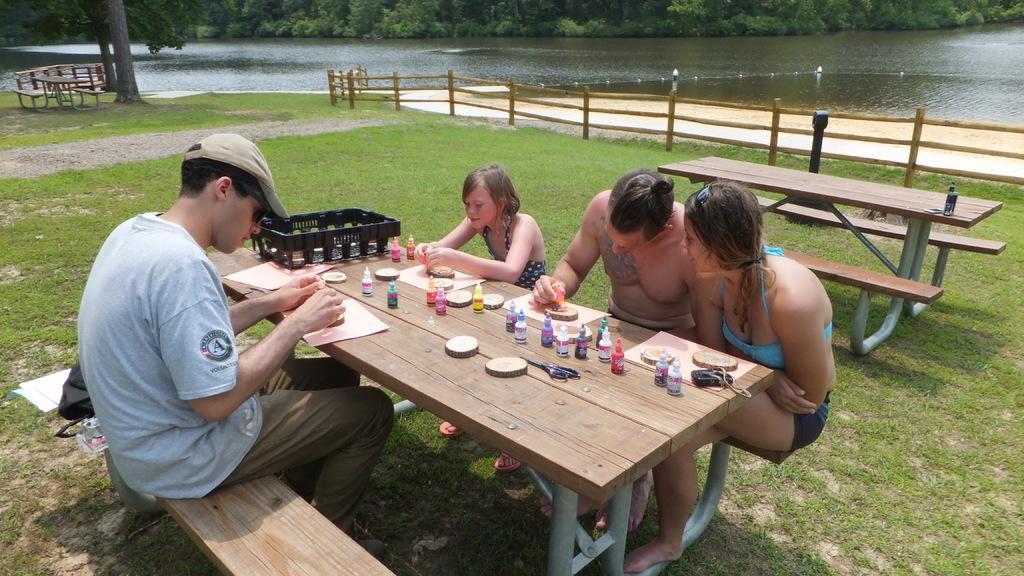Describe this image in one or two sentences. In the given image we can see there are four person sitting on bench. This is a table on which colors and papers are kept. Even we can see grass, water and trees. 